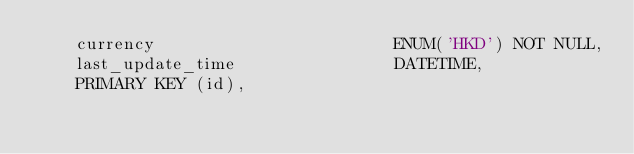Convert code to text. <code><loc_0><loc_0><loc_500><loc_500><_SQL_>    currency                        ENUM('HKD') NOT NULL,
    last_update_time                DATETIME,
    PRIMARY KEY (id),</code> 